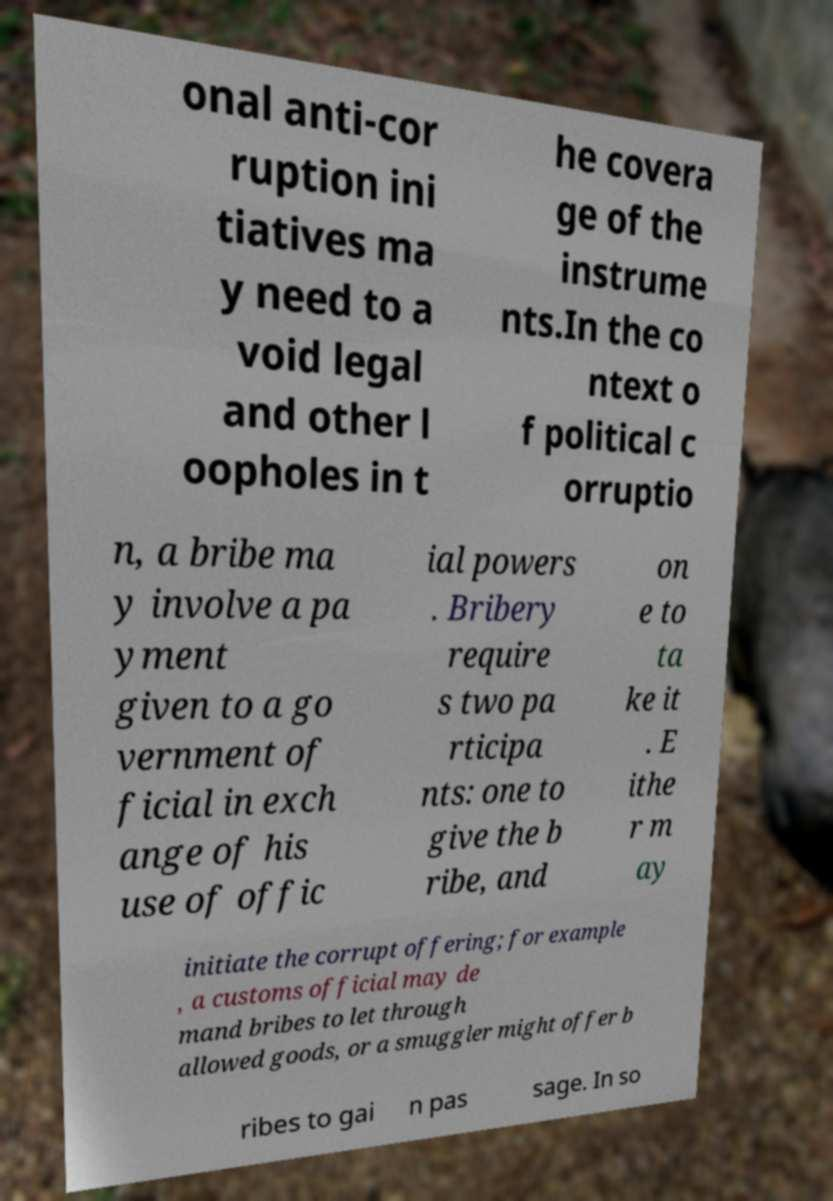Can you accurately transcribe the text from the provided image for me? onal anti-cor ruption ini tiatives ma y need to a void legal and other l oopholes in t he covera ge of the instrume nts.In the co ntext o f political c orruptio n, a bribe ma y involve a pa yment given to a go vernment of ficial in exch ange of his use of offic ial powers . Bribery require s two pa rticipa nts: one to give the b ribe, and on e to ta ke it . E ithe r m ay initiate the corrupt offering; for example , a customs official may de mand bribes to let through allowed goods, or a smuggler might offer b ribes to gai n pas sage. In so 